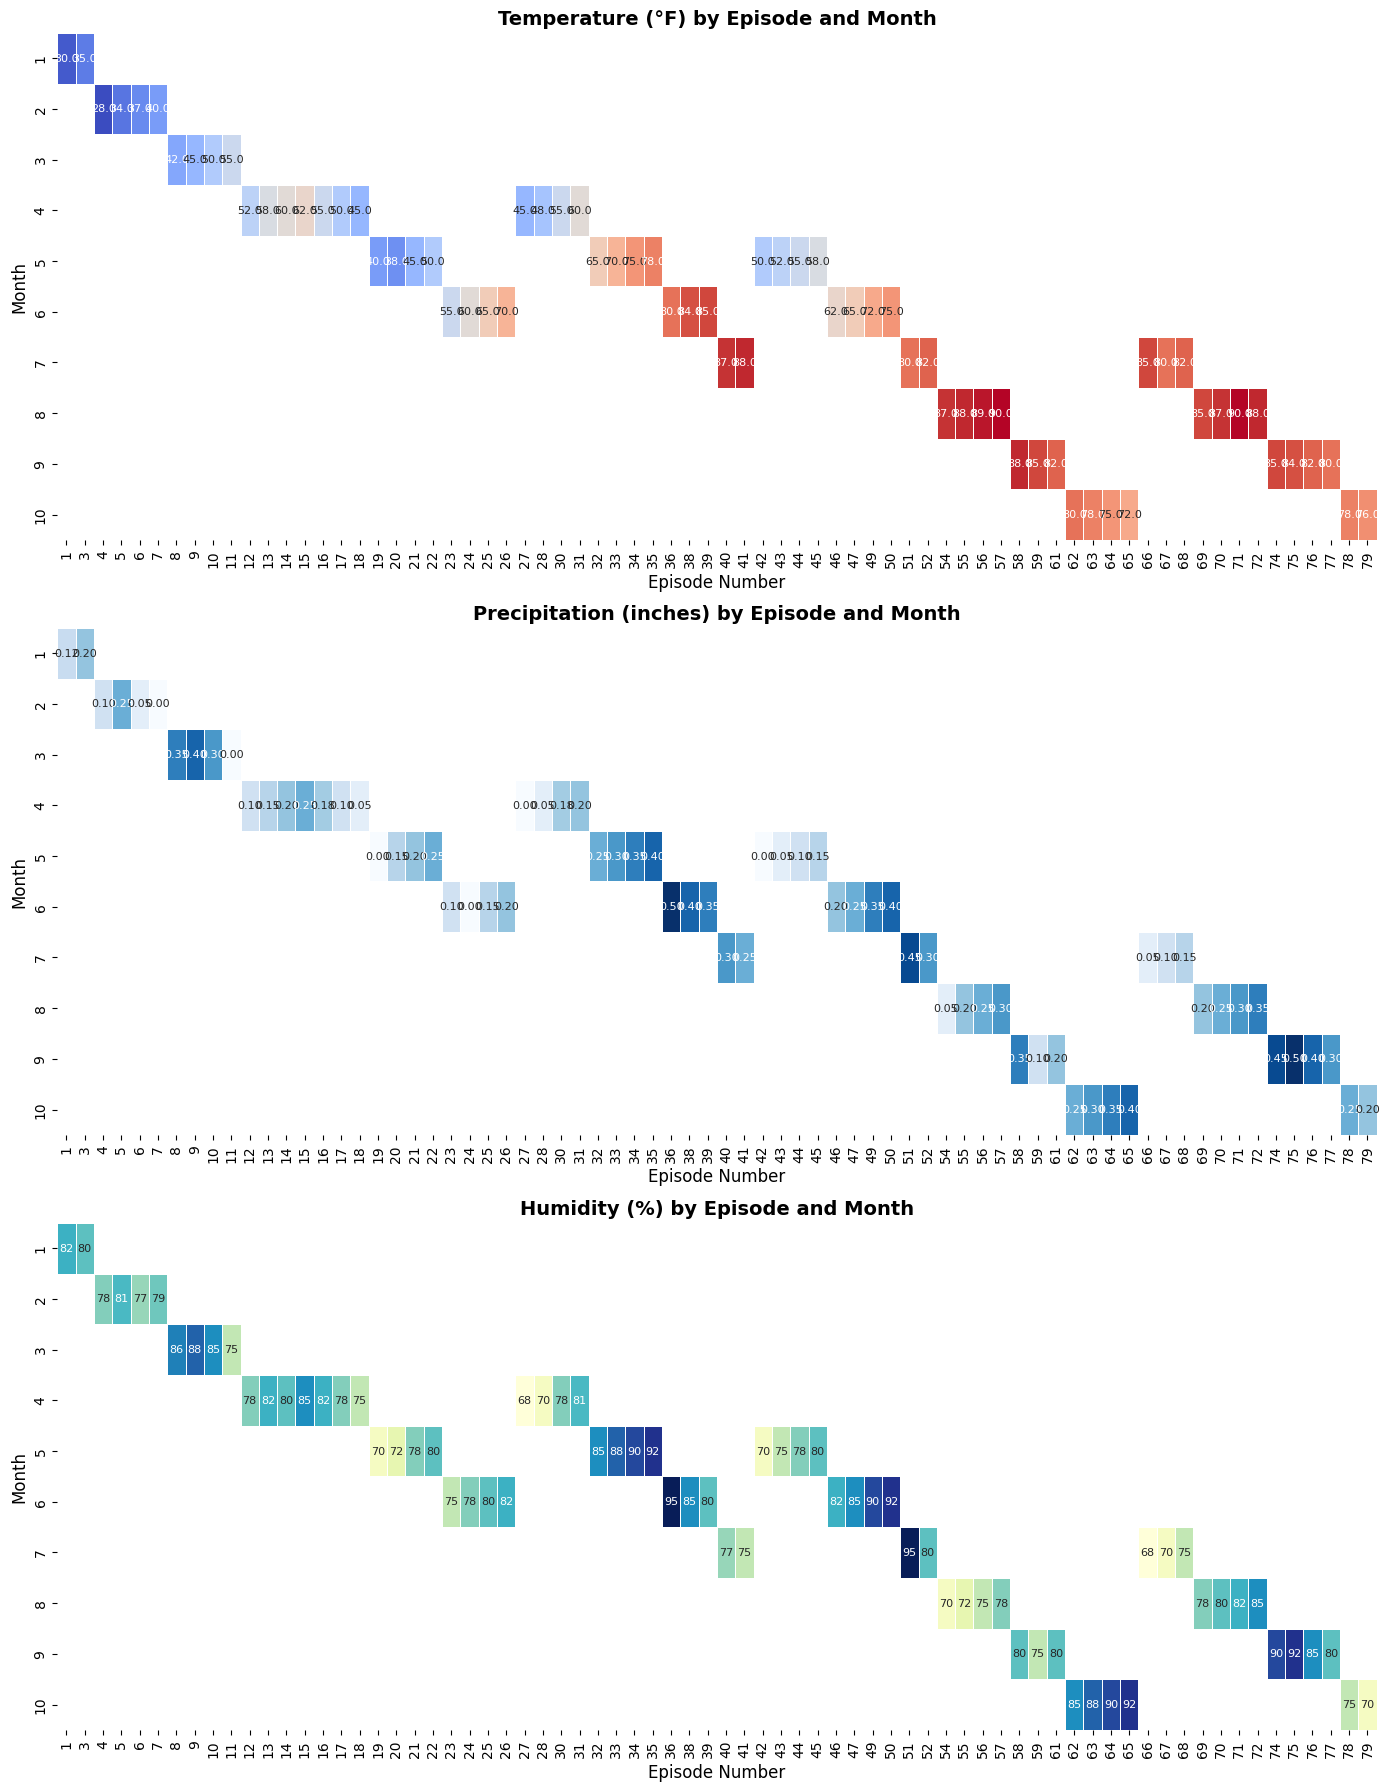Which month had the highest average temperature for episodes aired? Look at the temperature heatmap. Identify the month row with the most consistently high temperature cells.
Answer: July Between Episode 1 and Episode 11, which one had more consistent humidity levels? Look at the humidity heatmap. For each episode, note the range of humidity values. Episode 1 has blacker, more varied values, while Episode 11 has consistent lower values.
Answer: Episode 11 During which months was precipitation generally highest for the episodes aired? Check the precipitation heatmap. Identify the month rows with most cells in deeper blue shades indicating higher precipitation.
Answer: May and June What is the overall trend in temperature from January to December based on the episodes aired? Observe the temperature heatmap moving from the top (January) to the bottom (December). Identify whether the temperature intensifies or declines.
Answer: Increasing What was the average humidity for episodes aired in May across all seasons? Note down the humidity values in May rows. Calculate the average of these values. Add up the humidity values and divide by the number of entries.
Answer: 82% Comparing episodes in March and July, which month experienced less precipitation on average? Find the March and July rows in the precipitation heatmap. Compare the intensity of the blue shades. March seems lighter on average compared to July.
Answer: March What is the difference in temperature between Episode 1 in January and Episode 50 in June? Locate Episode 1 in the January row on the temperature heatmap and Episode 50 in the June row. Subtract the value of Episode 1 from Episode 50. E.g., 75 (June) - 30 (January)= 45°F
Answer: 45°F Which episode had the highest precipitation level aired in October? Check October rows in the precipitation heatmap. Identify the darkest blue cell corresponding to the episode.
Answer: Episode 65 How does the humidity pattern in August compare with that in September for episodes aired? Compare cells in the humidity heatmap in the August and September rows. August shows a lighter average color (lower values), while September exhibits darker shades (higher values).
Answer: August has lower humidity Which episode had the lowest temperature aired during April? Check the April row in the temperature heatmap. Find the pale (low value) cell corresponding to the episode.
Answer: Episode 18 